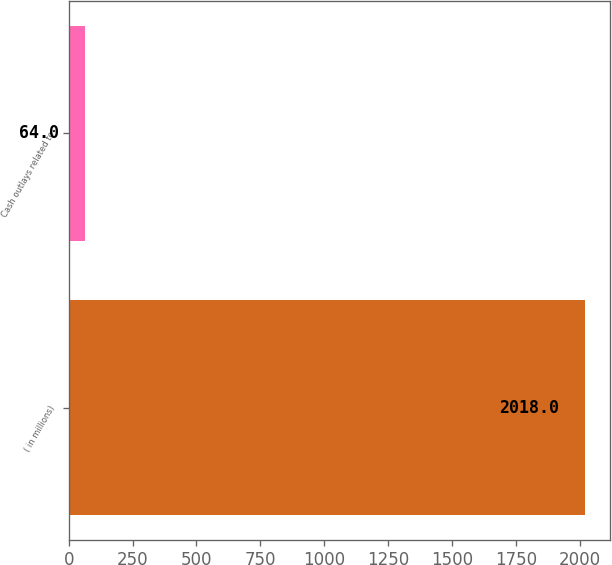<chart> <loc_0><loc_0><loc_500><loc_500><bar_chart><fcel>( in millions)<fcel>Cash outlays related to<nl><fcel>2018<fcel>64<nl></chart> 